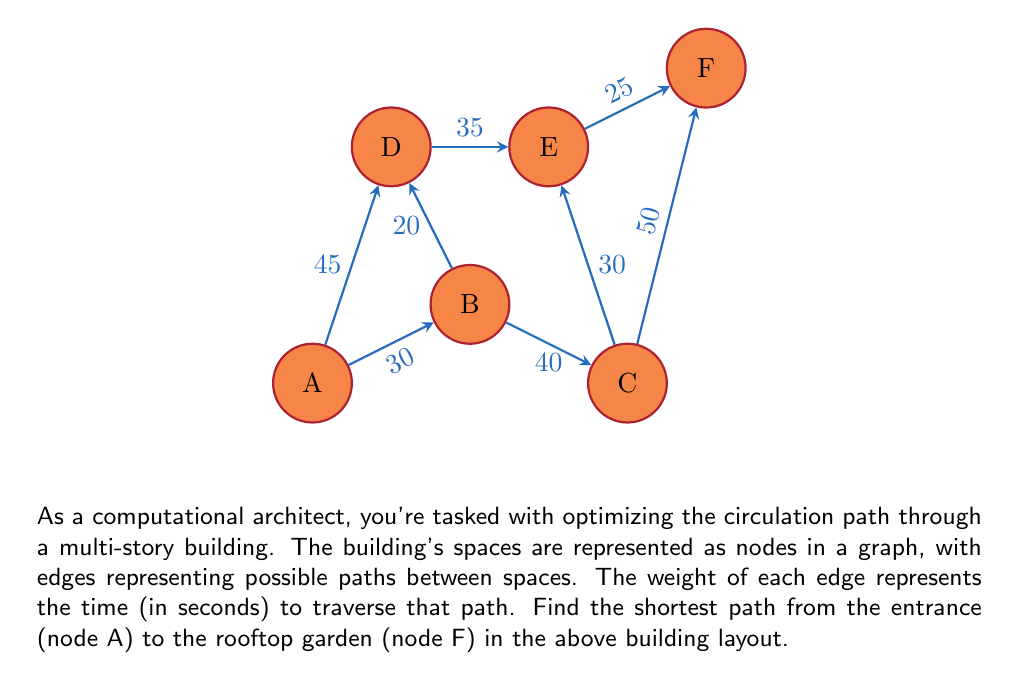Help me with this question. To solve this problem, we'll use Dijkstra's algorithm, which is an efficient method for finding the shortest path in a weighted graph.

Step 1: Initialize distances
Set the distance to the starting node A as 0, and all other nodes as infinity.
$d(A) = 0$, $d(B) = d(C) = d(D) = d(E) = d(F) = \infty$

Step 2: Create a priority queue with all nodes, prioritized by their distance.

Step 3: While the queue is not empty, do:
a) Extract the node with the minimum distance (initially A)
b) For each neighbor of the extracted node, calculate the distance through the current node
c) If this calculated distance is less than the previously recorded distance, update it

Iteration 1 (Node A):
Update $d(B) = 30$, $d(D) = 45$

Iteration 2 (Node B):
Update $d(C) = 70$, $d(D) = \min(45, 30 + 20) = 45$

Iteration 3 (Node D):
Update $d(E) = 45 + 35 = 80$

Iteration 4 (Node C):
Update $d(E) = \min(80, 70 + 30) = 80$, $d(F) = 70 + 50 = 120$

Iteration 5 (Node E):
Update $d(F) = \min(120, 80 + 25) = 105$

The algorithm terminates as we've reached the target node F.

Step 4: Backtrack to find the path
Starting from F, we choose the edge that gives us the correct distance at each step:
F <- E <- D <- A

Therefore, the shortest path is A -> D -> E -> F, with a total distance of 105 seconds.
Answer: A -> D -> E -> F, 105 seconds 